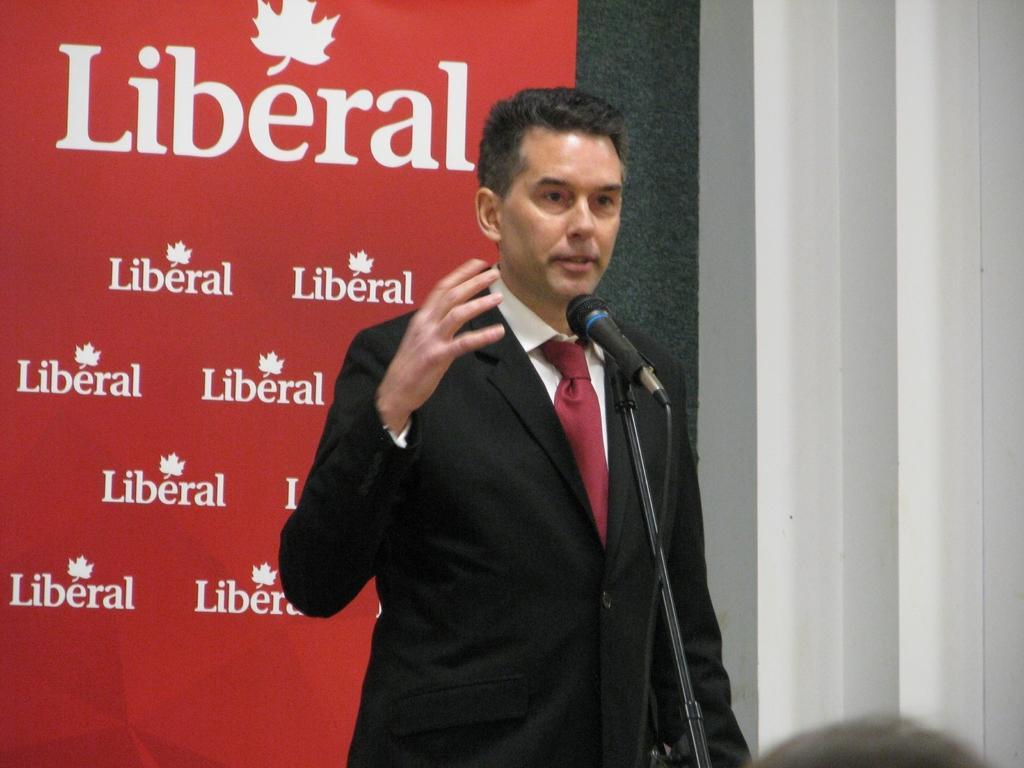Can you describe this image briefly? This image is taken indoors. In the background there is a wall and there is a banner with a text on it. In the middle of the image a man is standing and talking. There is a mic. At the right bottom of the image there is an object. 